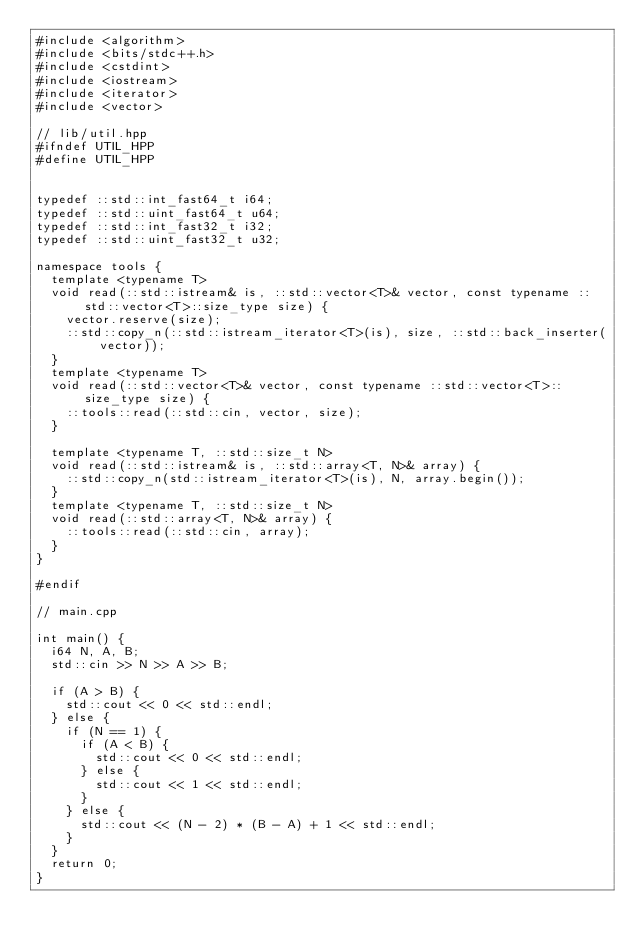<code> <loc_0><loc_0><loc_500><loc_500><_C++_>#include <algorithm>
#include <bits/stdc++.h>
#include <cstdint>
#include <iostream>
#include <iterator>
#include <vector>

// lib/util.hpp
#ifndef UTIL_HPP
#define UTIL_HPP


typedef ::std::int_fast64_t i64;
typedef ::std::uint_fast64_t u64;
typedef ::std::int_fast32_t i32;
typedef ::std::uint_fast32_t u32;

namespace tools {
  template <typename T>
  void read(::std::istream& is, ::std::vector<T>& vector, const typename ::std::vector<T>::size_type size) {
    vector.reserve(size);
    ::std::copy_n(::std::istream_iterator<T>(is), size, ::std::back_inserter(vector));
  }
  template <typename T>
  void read(::std::vector<T>& vector, const typename ::std::vector<T>::size_type size) {
    ::tools::read(::std::cin, vector, size);
  }

  template <typename T, ::std::size_t N>
  void read(::std::istream& is, ::std::array<T, N>& array) {
    ::std::copy_n(std::istream_iterator<T>(is), N, array.begin());
  }
  template <typename T, ::std::size_t N>
  void read(::std::array<T, N>& array) {
    ::tools::read(::std::cin, array);
  }
}

#endif

// main.cpp

int main() {
  i64 N, A, B;
  std::cin >> N >> A >> B;

  if (A > B) {
    std::cout << 0 << std::endl;
  } else {
    if (N == 1) {
      if (A < B) {
        std::cout << 0 << std::endl;
      } else {
        std::cout << 1 << std::endl;
      }
    } else {
      std::cout << (N - 2) * (B - A) + 1 << std::endl;
    }
  }
  return 0;
}</code> 